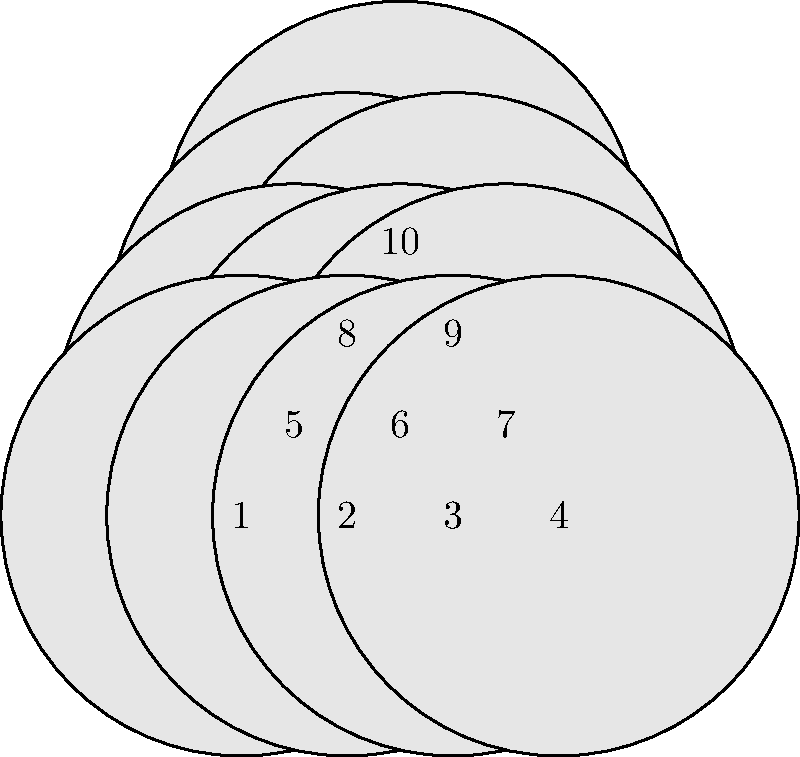As a bowling equipment expert, you're often asked about the mathematics behind the game. Consider the standard 10-pin bowling setup shown above. How many unique ways can you rearrange these 10 pins, assuming each pin is distinct? In other words, what is the order of the permutation group for this setup? To determine the order of the permutation group for the 10-pin bowling setup, we need to follow these steps:

1. Recognize that each pin is considered distinct, meaning we can treat this as a straightforward permutation problem.

2. Recall that for n distinct objects, the number of possible permutations is given by n! (n factorial).

3. In this case, we have 10 distinct pins, so n = 10.

4. Calculate 10!:
   $$10! = 10 \times 9 \times 8 \times 7 \times 6 \times 5 \times 4 \times 3 \times 2 \times 1$$

5. Compute the result:
   $$10! = 3,628,800$$

6. This number represents the total number of unique ways to arrange the 10 pins, which is also the order of the permutation group for this setup.

7. In group theory terms, this permutation group is isomorphic to the symmetric group $S_{10}$, which has order 10!.
Answer: 3,628,800 